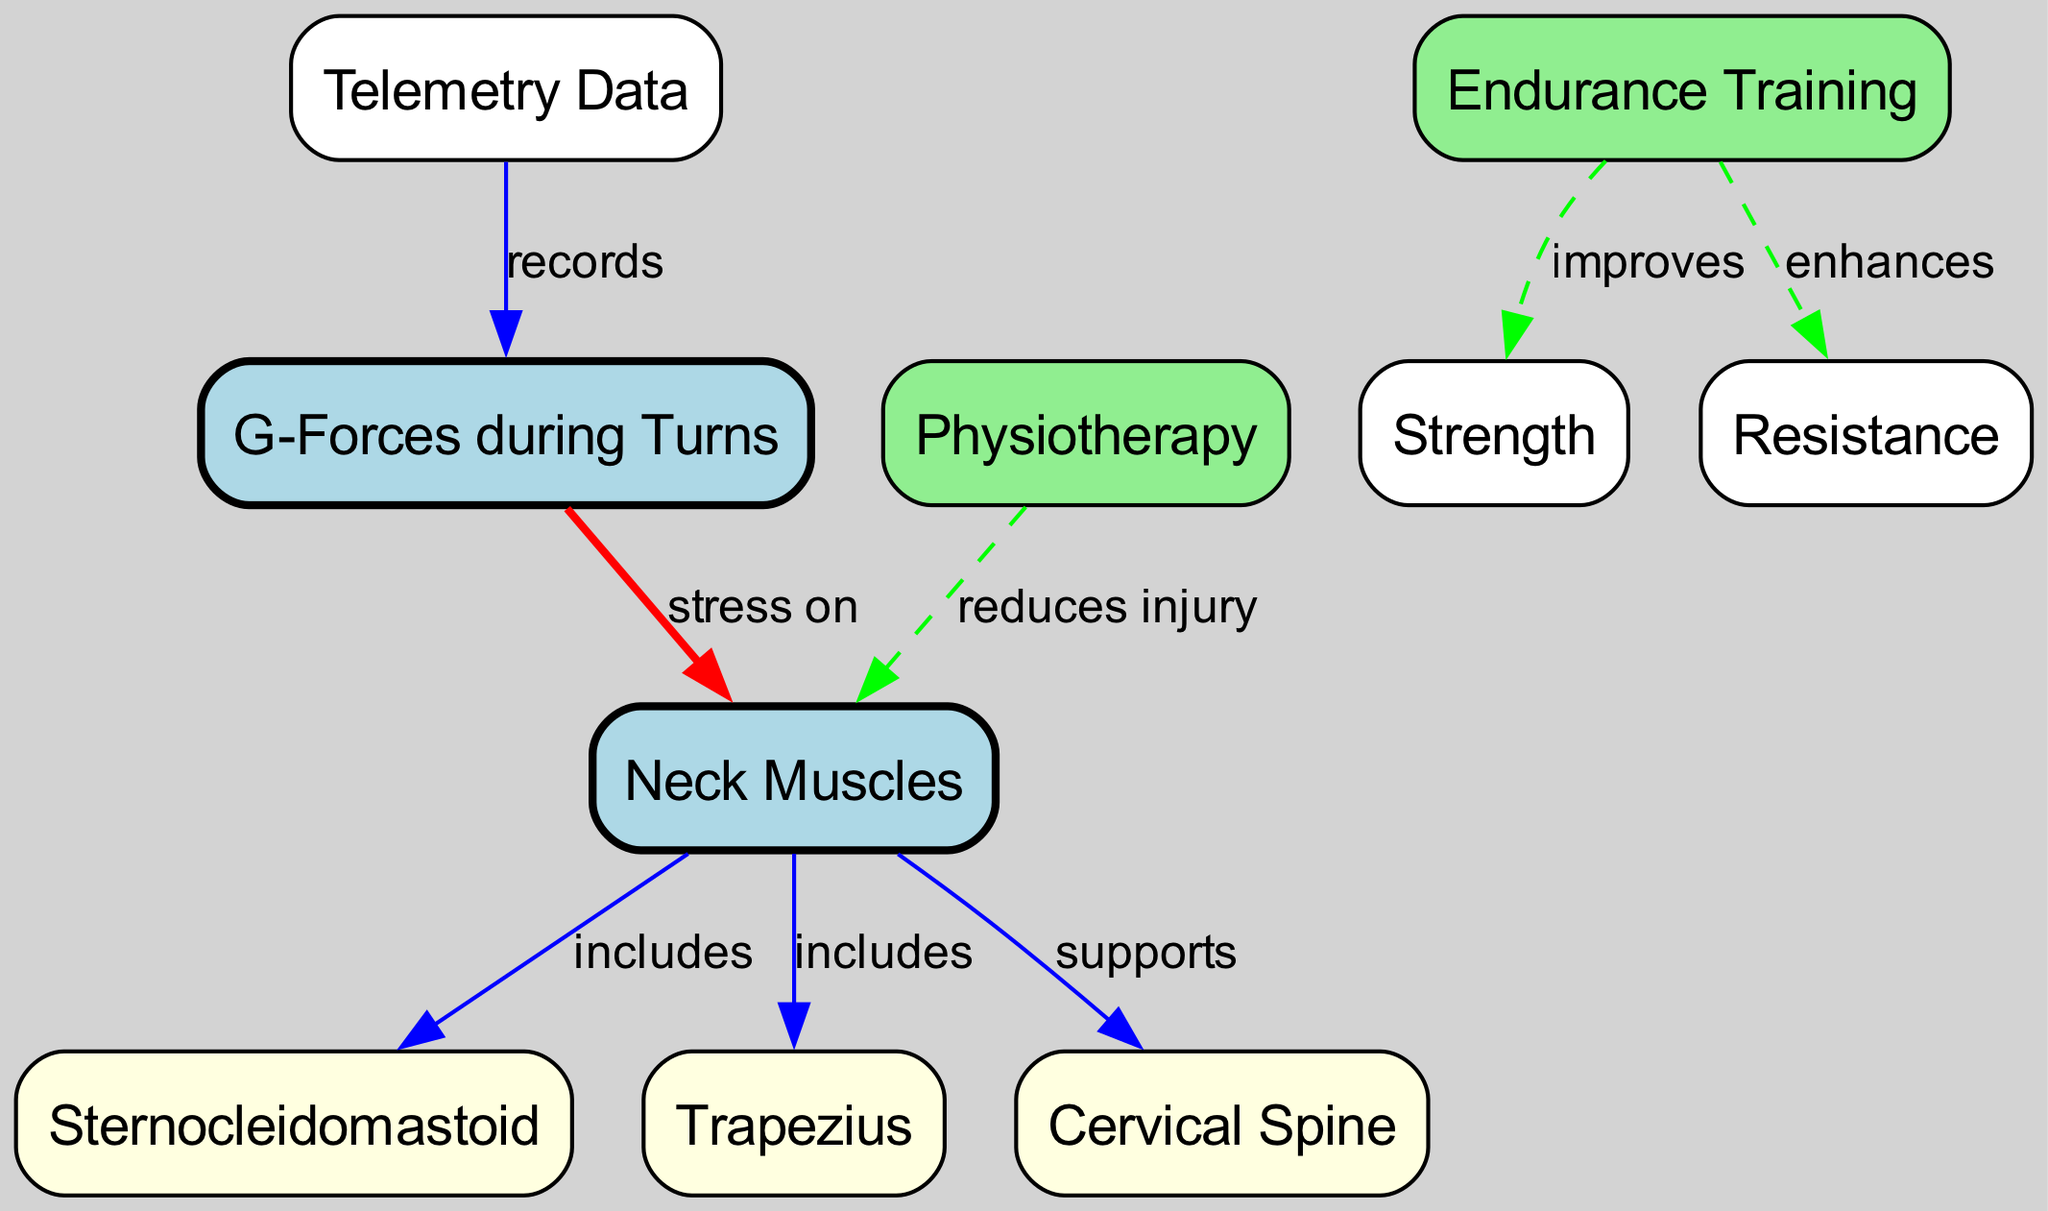What are the two main muscles included in the neck muscles? The diagram specifically highlights "Sternocleidomastoid" and "Trapezius" as the components of "Neck Muscles" through inclusion relationships indicated by the edges.
Answer: Sternocleidomastoid, Trapezius How many nodes are present in this diagram? The diagram contains a total of 10 nodes, which can be counted directly, including "Neck Muscles," "Sternocleidomastoid," "Trapezius," "Cervical Spine," "G-Forces during Turns," "Endurance Training," "Strength," "Resistance," "Physiotherapy," and "Telemetry Data."
Answer: 10 What does the "G-Forces" node exert stress on? The "G-Forces during Turns" node specifically indicates that it applies stress to the "Neck Muscles," as represented by the directed edge connecting them.
Answer: Neck Muscles What effect does "Endurance Training" have on "Strength"? According to the edge indicating a relationship, "Endurance Training" improves "Strength." This is noted along the directed edge that connects these two nodes, showing the positive impact of endurance training.
Answer: improves What type of training enhances resistance? The relationship depicted in the diagram shows that "Endurance Training" enhances "Resistance," as indicated by the directed edge labeled accordingly.
Answer: Endurance Training Which node records the G-Forces? The "Telemetry Data" node records "G-Forces during Turns," as explicitly shown by the directed edge leading from "Telemetry Data" to "G-Forces."
Answer: Telemetry Data How does "Physiotherapy" impact neck muscles? The diagram illustrates that "Physiotherapy" reduces injury to "Neck Muscles," indicated by the dashed edge connecting these two nodes. This suggests a protective and rehabilitative effect.
Answer: reduces injury What supports the "Neck Muscles"? The "Cervical Spine" node is indicated as a support for "Neck Muscles" through a directed edge, highlighting its structural role in neck biomechanics.
Answer: Cervical Spine How many relationships are there between nodes in the diagram? There are 8 edges or relationships connecting the different nodes in the diagram, each indicating interactions or effects between the components.
Answer: 8 